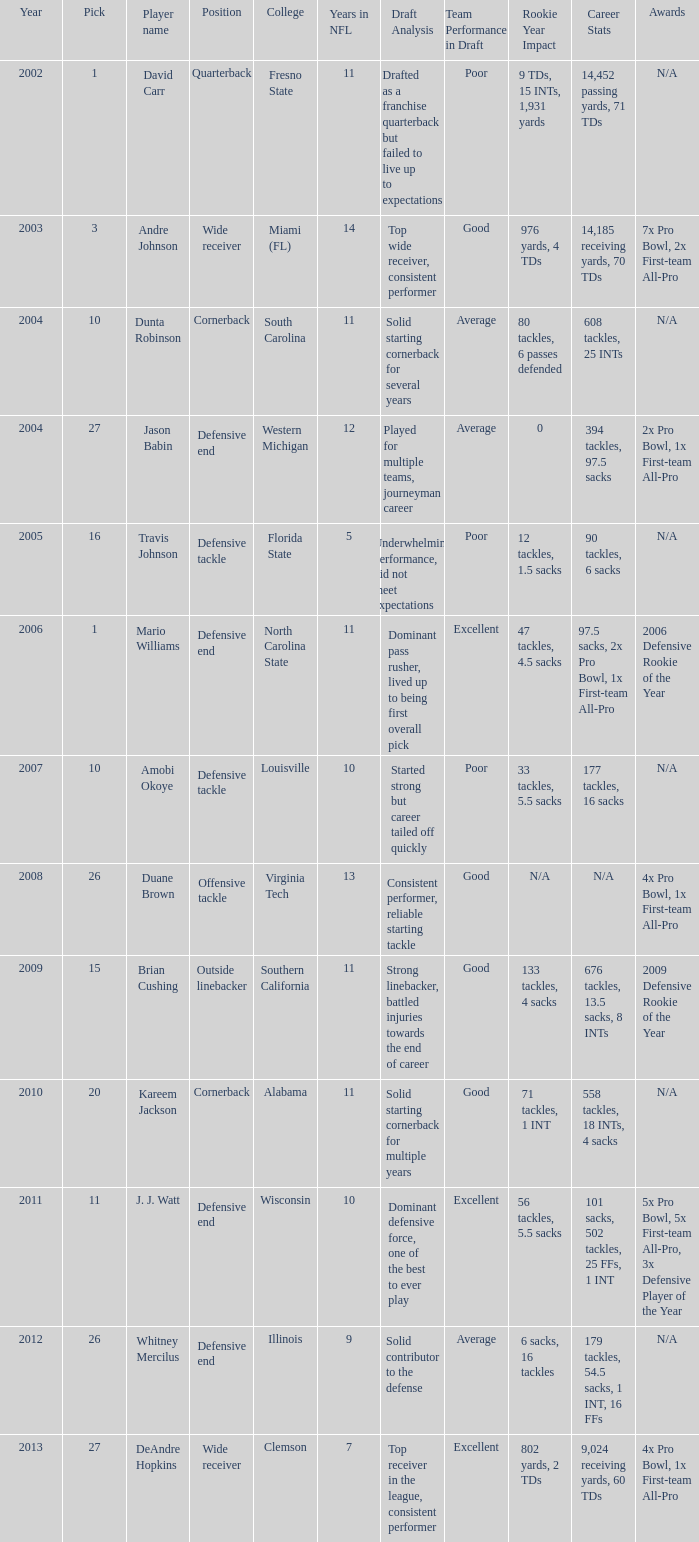What pick was mario williams before 2006? None. 